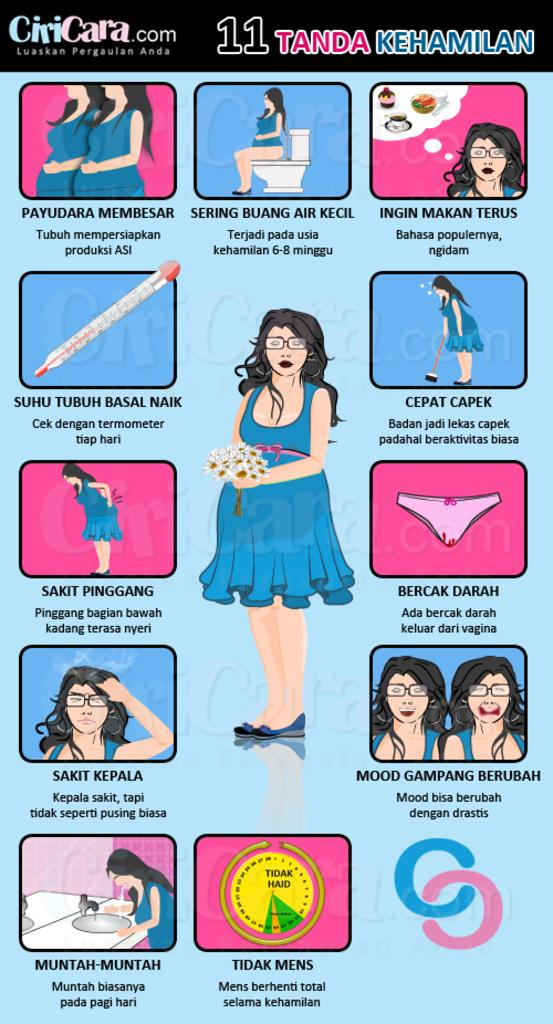What is present on the poster in the image? There is a poster in the image, which contains cartoon images. What else can be seen on the poster besides the cartoon images? There is text on the poster. How many times does the spoon appear in the image? There is no spoon present in the image. What type of adjustment is needed for the fold in the image? There is no fold present in the image. 